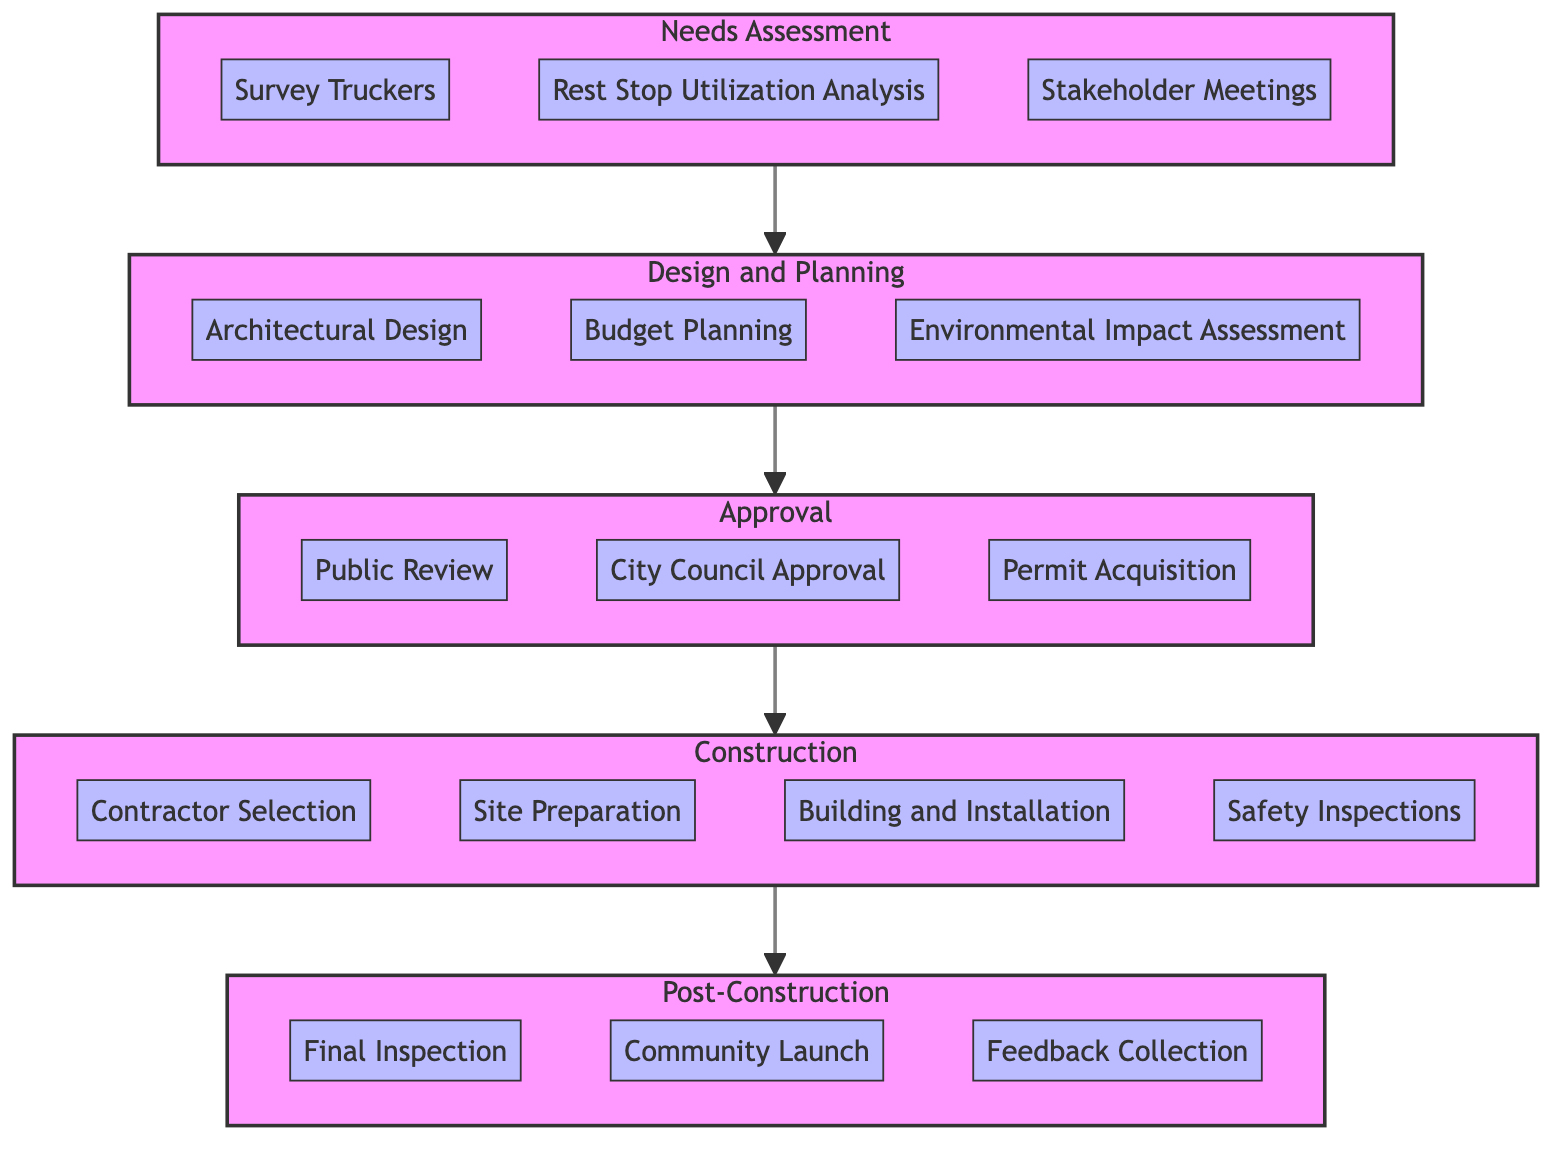What is the first phase of the Clinical Pathway? The first phase is labeled at the top of the diagram, indicating the beginning of the process. It is the "Needs Assessment" phase.
Answer: Needs Assessment How many tasks are there in the Approval phase? The diagram shows three tasks listed under the "Approval" phase, allowing us to count them directly.
Answer: 3 Which responsible entity is tasked with conducting safety inspections? By examining the tasks under the "Construction" phase, the responsible entity for conducting safety inspections is clearly stated as "Safety Compliance Officers."
Answer: Safety Compliance Officers What is the last task in the Post-Construction phase? The last task in this phase can be found at the bottom of that specific section in the diagram, which details the final tasks. It is "Feedback Collection."
Answer: Feedback Collection Which phase comes after Design and Planning? The flow of the diagram shows a direct connection from the "Design and Planning" phase to the next phase, which indicates the sequential order of the phases. The phase that follows is "Approval."
Answer: Approval What is the primary responsible entity for the Architectural Design task? By looking at the specific task under the "Design and Planning" phase, we can identify the responsible entity stated there as "City Infrastructure Committee."
Answer: City Infrastructure Committee How many phases are represented in the Clinical Pathway diagram? The total number of distinct phases can be counted directly from the main headings of the diagram. There are five phases indicated in total.
Answer: 5 What type of assessment is required before the Approval phase? The task listed in the "Design and Planning" phase concerning assessments indicates that an "Environmental Impact Assessment" must be conducted.
Answer: Environmental Impact Assessment Which entity is responsible for submitting the plans and budget to the city council? This responsibility can be identified in the "Approval" phase, specifically under the relevant task, which notes the responsible entity as "City Council."
Answer: City Council 